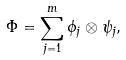<formula> <loc_0><loc_0><loc_500><loc_500>\Phi = \sum _ { j = 1 } ^ { m } \phi _ { j } \otimes \psi _ { j } ,</formula> 